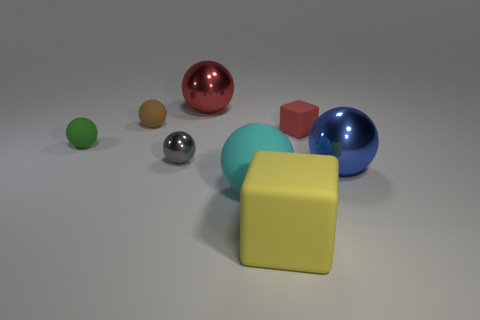What is the texture and material appearance of the objects? The objects exhibit varied textures; the spheres and the cube have a smooth and reflective surface, suggesting a metallic or polished plastic material.  Is there an object that appears different in material or texture from the others? All the objects have similar reflective materials. However, the tiny brown sphere seems slightly less reflective, which may indicate a different texture or material, such as rubber. 